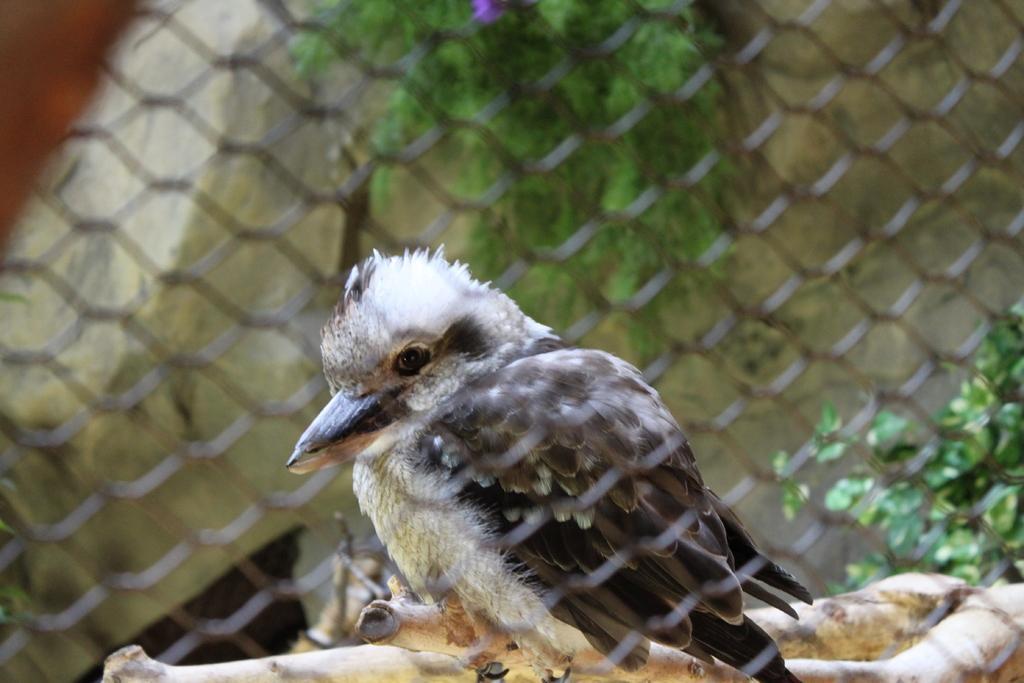In one or two sentences, can you explain what this image depicts? In the image there is net in the front and behind there is a bird standing on the wooden block and behind there are plants. 